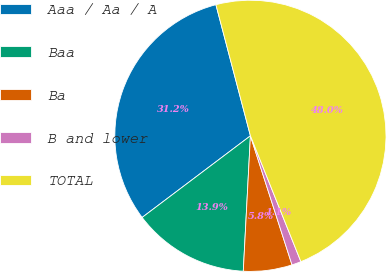<chart> <loc_0><loc_0><loc_500><loc_500><pie_chart><fcel>Aaa / Aa / A<fcel>Baa<fcel>Ba<fcel>B and lower<fcel>TOTAL<nl><fcel>31.18%<fcel>13.88%<fcel>5.8%<fcel>1.11%<fcel>48.02%<nl></chart> 